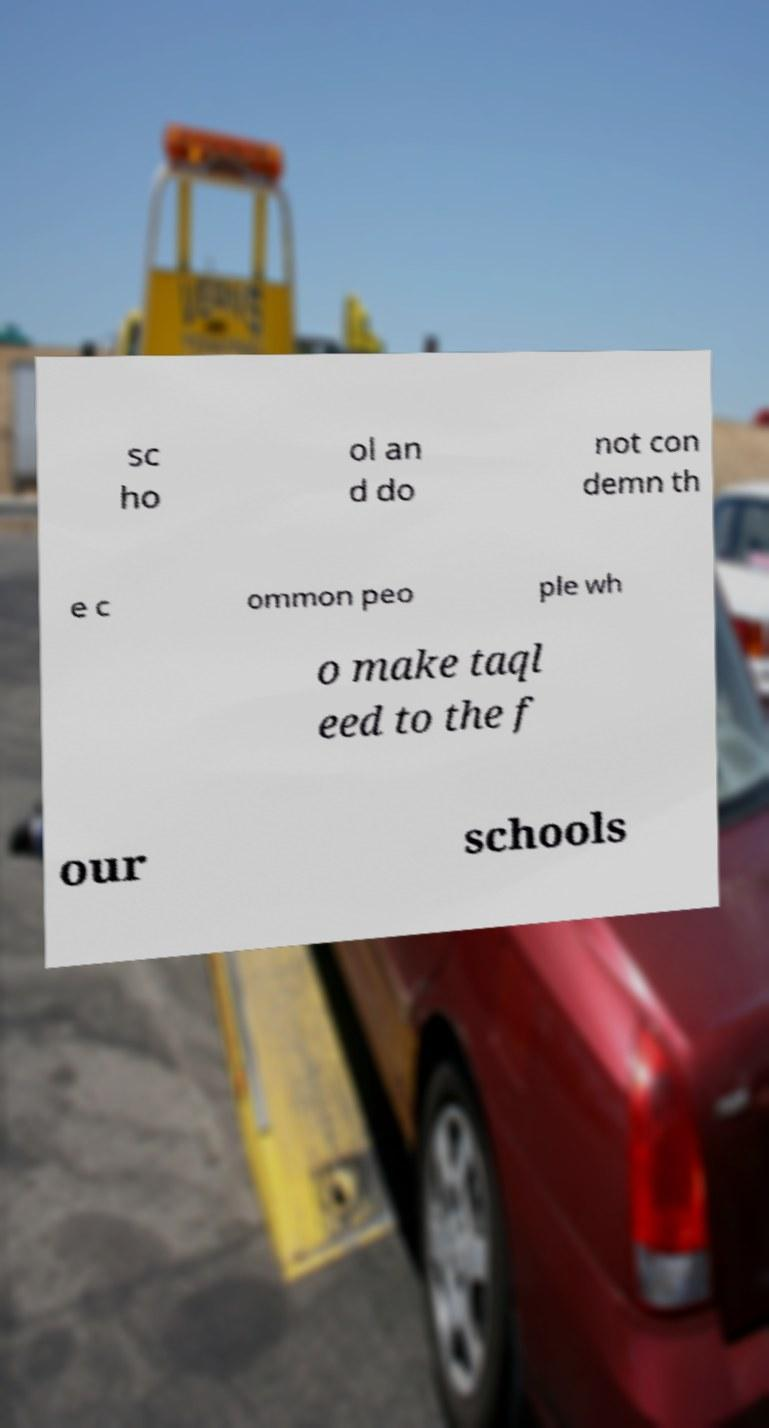Please identify and transcribe the text found in this image. sc ho ol an d do not con demn th e c ommon peo ple wh o make taql eed to the f our schools 